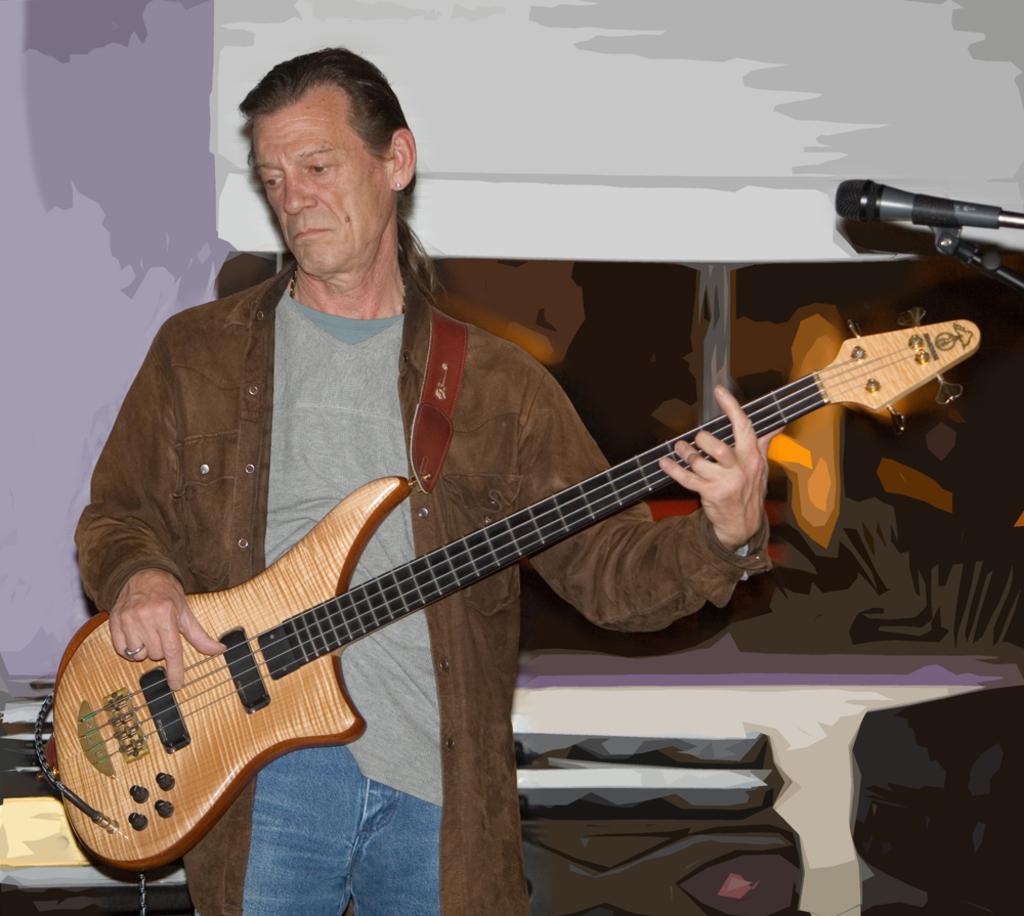Describe this image in one or two sentences. As we can see in the image there is a man holding guitar. 